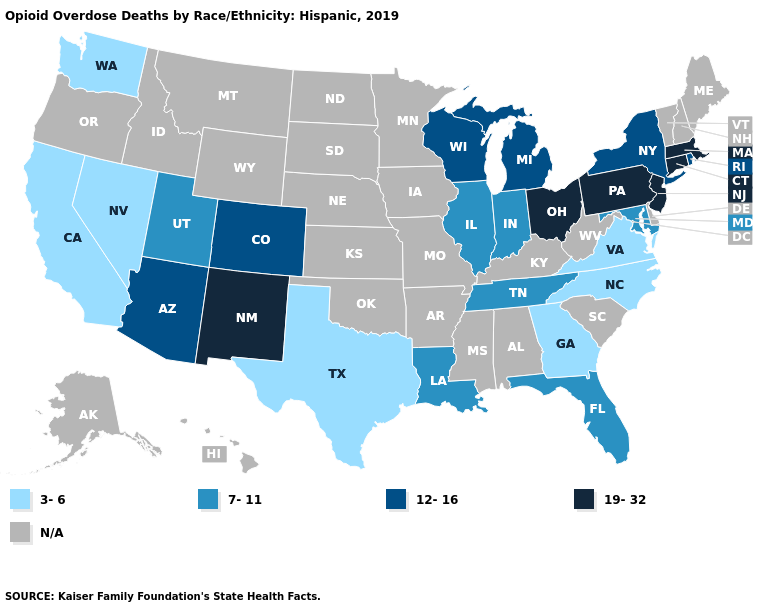Among the states that border New Jersey , which have the highest value?
Short answer required. Pennsylvania. What is the lowest value in the Northeast?
Concise answer only. 12-16. What is the value of Idaho?
Short answer required. N/A. Does the first symbol in the legend represent the smallest category?
Short answer required. Yes. What is the lowest value in states that border Nevada?
Answer briefly. 3-6. What is the value of New Jersey?
Answer briefly. 19-32. Which states hav the highest value in the South?
Concise answer only. Florida, Louisiana, Maryland, Tennessee. What is the value of Florida?
Short answer required. 7-11. What is the value of New Hampshire?
Give a very brief answer. N/A. What is the value of New York?
Keep it brief. 12-16. Name the states that have a value in the range N/A?
Concise answer only. Alabama, Alaska, Arkansas, Delaware, Hawaii, Idaho, Iowa, Kansas, Kentucky, Maine, Minnesota, Mississippi, Missouri, Montana, Nebraska, New Hampshire, North Dakota, Oklahoma, Oregon, South Carolina, South Dakota, Vermont, West Virginia, Wyoming. Is the legend a continuous bar?
Answer briefly. No. Name the states that have a value in the range 19-32?
Concise answer only. Connecticut, Massachusetts, New Jersey, New Mexico, Ohio, Pennsylvania. Which states hav the highest value in the MidWest?
Write a very short answer. Ohio. 